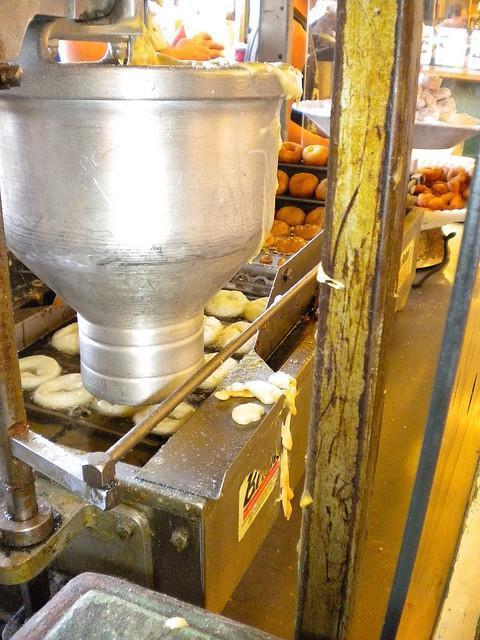How many giraffes are there?
Give a very brief answer. 0. 